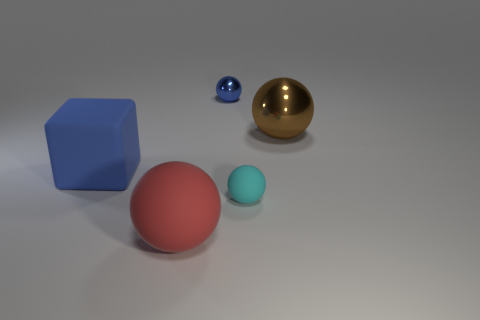Subtract all small metallic balls. How many balls are left? 3 Add 5 cyan rubber objects. How many objects exist? 10 Subtract 1 spheres. How many spheres are left? 3 Subtract all cyan spheres. How many spheres are left? 3 Subtract all green balls. Subtract all green cylinders. How many balls are left? 4 Subtract all balls. How many objects are left? 1 Subtract all blue metallic blocks. Subtract all big matte objects. How many objects are left? 3 Add 1 cyan things. How many cyan things are left? 2 Add 4 large rubber cylinders. How many large rubber cylinders exist? 4 Subtract 1 brown balls. How many objects are left? 4 